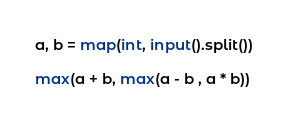Convert code to text. <code><loc_0><loc_0><loc_500><loc_500><_Python_>a, b = map(int, input().split())

max(a + b, max(a - b , a * b))</code> 